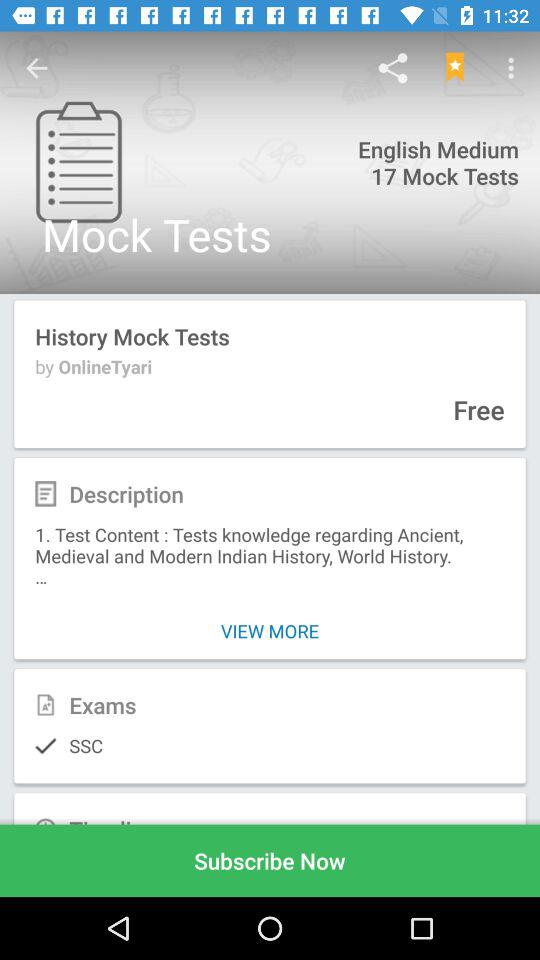What application is asking for permission? The application is Onlinetyari. 